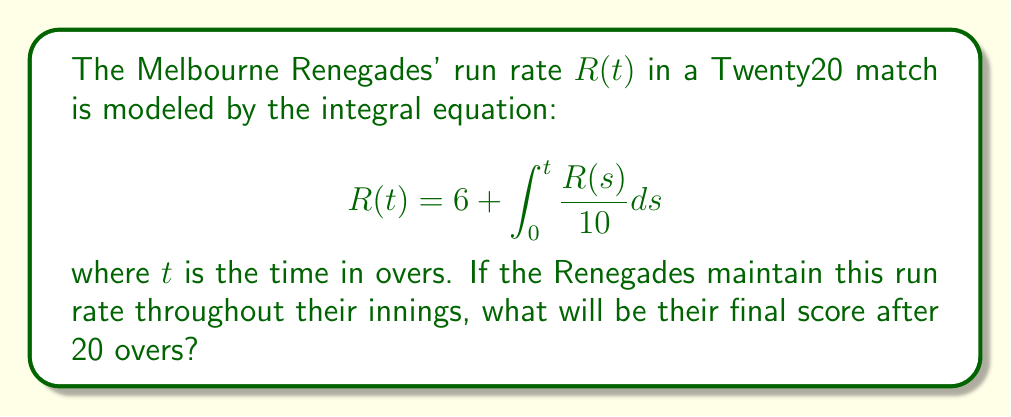Can you solve this math problem? Let's solve this step-by-step:

1) First, we need to solve the integral equation for $R(t)$. This is a Volterra integral equation of the second kind.

2) To solve it, we differentiate both sides with respect to $t$:

   $$\frac{dR}{dt} = \frac{R(t)}{10}$$

3) This is a separable differential equation. We can rewrite it as:

   $$\frac{dR}{R} = \frac{1}{10}dt$$

4) Integrating both sides:

   $$\ln|R| = \frac{t}{10} + C$$

5) Taking the exponential of both sides:

   $$R = Ae^{t/10}$$

   where $A = e^C$ is a constant.

6) To find $A$, we use the initial condition from the original equation: $R(0) = 6$

   $$6 = Ae^{0/10} = A$$

7) Therefore, the solution to the integral equation is:

   $$R(t) = 6e^{t/10}$$

8) To find the final score after 20 overs, we need to integrate $R(t)$ from 0 to 20:

   $$\text{Score} = \int_0^{20} R(t) dt = \int_0^{20} 6e^{t/10} dt$$

9) Solving this integral:

   $$\text{Score} = 6 \cdot 10 \cdot [e^{t/10}]_0^{20} = 60(e^2 - 1) \approx 163.7$$

10) Since cricket scores are always whole numbers, we round down to 163.
Answer: 163 runs 